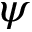<formula> <loc_0><loc_0><loc_500><loc_500>\psi</formula> 